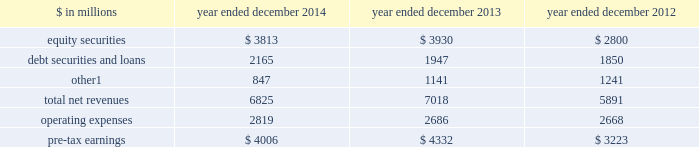Management 2019s discussion and analysis investing & lending investing & lending includes our investing activities and the origination of loans to provide financing to clients .
These investments and loans are typically longer-term in nature .
We make investments , some of which are consolidated , directly and indirectly through funds that we manage , in debt securities and loans , public and private equity securities , and real estate entities .
The table below presents the operating results of our investing & lending segment. .
Includes net revenues of $ 325 million for 2014 , $ 329 million for 2013 and $ 362 million for 2012 related to metro international trade services llc .
We completed the sale of this consolidated investment in december 2014 .
2014 versus 2013 .
Net revenues in investing & lending were $ 6.83 billion for 2014 , 3% ( 3 % ) lower than 2013 .
Net gains from investments in equity securities were slightly lower due to a significant decrease in net gains from investments in public equities , as movements in global equity prices during 2014 were less favorable compared with 2013 , partially offset by an increase in net gains from investments in private equities , primarily driven by company-specific events .
Net revenues from debt securities and loans were higher than 2013 , reflecting a significant increase in net interest income , primarily driven by increased lending , and a slight increase in net gains , primarily due to sales of certain investments during 2014 .
Other net revenues , related to our consolidated investments , were significantly lower compared with 2013 , reflecting a decrease in operating revenues from commodities-related consolidated investments .
During 2014 , net revenues in investing & lending generally reflected favorable company-specific events , including initial public offerings and financings , and strong corporate performance , as well as net gains from sales of certain investments .
However , concerns about the outlook for the global economy and uncertainty over the impact of financial regulatory reform continue to be meaningful considerations for the global marketplace .
If equity markets decline or credit spreads widen , net revenues in investing & lending would likely be negatively impacted .
Operating expenses were $ 2.82 billion for 2014 , 5% ( 5 % ) higher than 2013 , reflecting higher compensation and benefits expenses , partially offset by lower expenses related to consolidated investments .
Pre-tax earnings were $ 4.01 billion in 2014 , 8% ( 8 % ) lower than 2013 .
2013 versus 2012 .
Net revenues in investing & lending were $ 7.02 billion for 2013 , 19% ( 19 % ) higher than 2012 , reflecting a significant increase in net gains from investments in equity securities , driven by company-specific events and stronger corporate performance , as well as significantly higher global equity prices .
In addition , net gains and net interest income from debt securities and loans were slightly higher , while other net revenues , related to our consolidated investments , were lower compared with 2012 .
During 2013 , net revenues in investing & lending generally reflected favorable company-specific events and strong corporate performance , as well as the impact of significantly higher global equity prices and tighter corporate credit spreads .
Operating expenses were $ 2.69 billion for 2013 , essentially unchanged compared with 2012 .
Operating expenses during 2013 included lower impairment charges and lower operating expenses related to consolidated investments , partially offset by increased compensation and benefits expenses due to higher net revenues compared with 2012 .
Pre-tax earnings were $ 4.33 billion in 2013 , 34% ( 34 % ) higher than 2012 .
Goldman sachs 2014 annual report 45 .
In 2014 what percentage of total net revenues for the investing & lending segment were due to debt securities and loans? 
Computations: (2165 / 6825)
Answer: 0.31722. 